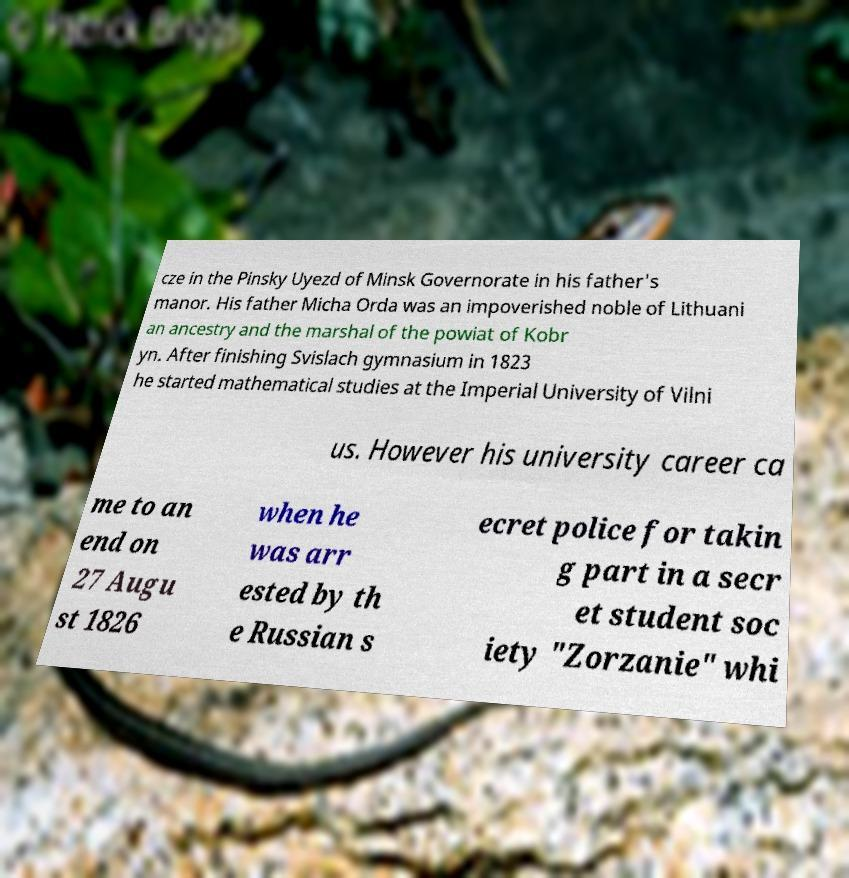I need the written content from this picture converted into text. Can you do that? cze in the Pinsky Uyezd of Minsk Governorate in his father's manor. His father Micha Orda was an impoverished noble of Lithuani an ancestry and the marshal of the powiat of Kobr yn. After finishing Svislach gymnasium in 1823 he started mathematical studies at the Imperial University of Vilni us. However his university career ca me to an end on 27 Augu st 1826 when he was arr ested by th e Russian s ecret police for takin g part in a secr et student soc iety "Zorzanie" whi 